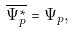<formula> <loc_0><loc_0><loc_500><loc_500>\overline { \Psi ^ { * } _ { p } } = \Psi _ { p } ,</formula> 